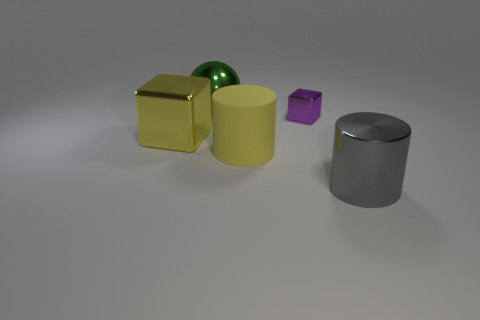What is the size of the metallic thing that is both in front of the small purple metallic cube and on the left side of the large gray object?
Your answer should be compact. Large. Do the yellow thing that is in front of the yellow block and the big metallic thing right of the tiny block have the same shape?
Make the answer very short. Yes. There is another big thing that is the same color as the big rubber object; what shape is it?
Give a very brief answer. Cube. What number of big green objects have the same material as the sphere?
Offer a very short reply. 0. There is a big metallic object that is both to the left of the big yellow matte cylinder and in front of the metallic ball; what is its shape?
Ensure brevity in your answer.  Cube. Is the cube that is left of the tiny purple thing made of the same material as the yellow cylinder?
Your response must be concise. No. Is there anything else that is made of the same material as the yellow cylinder?
Offer a very short reply. No. What color is the rubber object that is the same size as the yellow metal thing?
Your response must be concise. Yellow. Is there another large object of the same color as the big rubber object?
Make the answer very short. Yes. The purple block that is the same material as the big gray cylinder is what size?
Keep it short and to the point. Small. 